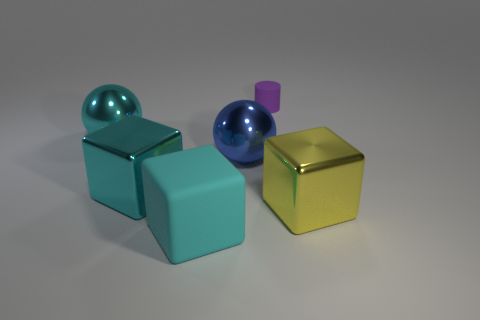What number of balls are tiny gray things or yellow things?
Provide a succinct answer. 0. There is a large cyan metallic object on the left side of the cyan metal cube; are there any small matte objects that are right of it?
Keep it short and to the point. Yes. There is a large yellow metallic object; is it the same shape as the rubber object in front of the tiny purple object?
Offer a very short reply. Yes. What number of other objects are there of the same size as the yellow thing?
Keep it short and to the point. 4. How many green objects are big cylinders or metal spheres?
Provide a short and direct response. 0. What number of matte objects are both to the right of the big blue shiny ball and in front of the small purple cylinder?
Provide a succinct answer. 0. The big cyan thing that is on the left side of the large shiny cube that is left of the metallic cube that is right of the purple object is made of what material?
Provide a short and direct response. Metal. What number of cyan things are the same material as the small purple cylinder?
Make the answer very short. 1. There is a blue shiny thing that is the same size as the cyan rubber object; what is its shape?
Provide a short and direct response. Sphere. Are there any purple matte objects behind the large yellow thing?
Offer a very short reply. Yes. 